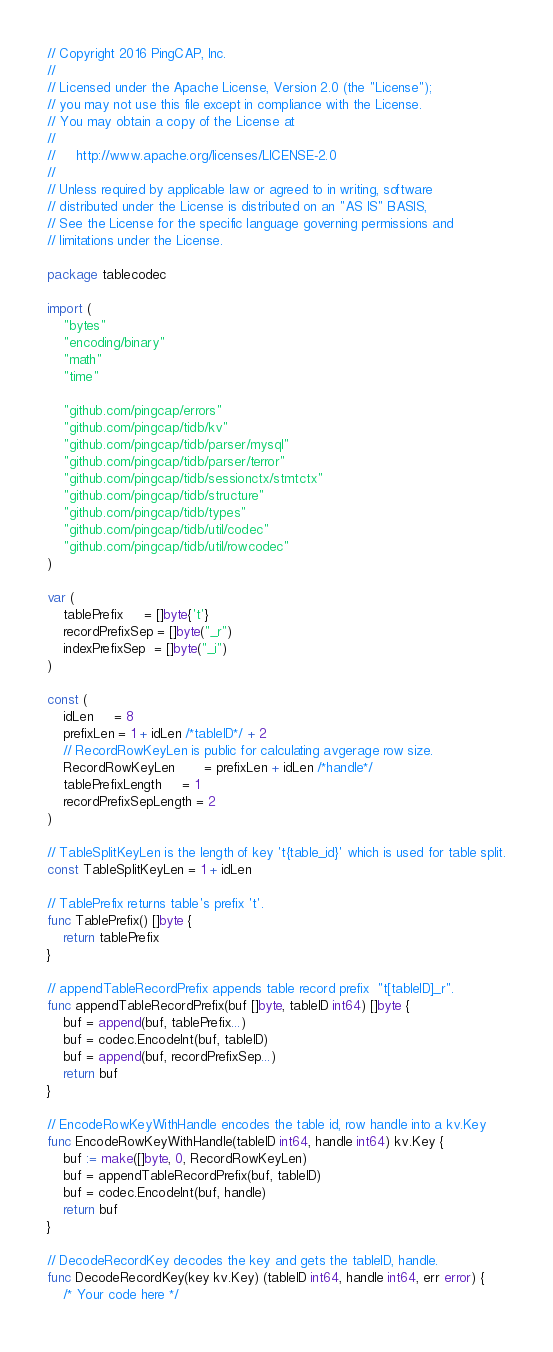Convert code to text. <code><loc_0><loc_0><loc_500><loc_500><_Go_>// Copyright 2016 PingCAP, Inc.
//
// Licensed under the Apache License, Version 2.0 (the "License");
// you may not use this file except in compliance with the License.
// You may obtain a copy of the License at
//
//     http://www.apache.org/licenses/LICENSE-2.0
//
// Unless required by applicable law or agreed to in writing, software
// distributed under the License is distributed on an "AS IS" BASIS,
// See the License for the specific language governing permissions and
// limitations under the License.

package tablecodec

import (
	"bytes"
	"encoding/binary"
	"math"
	"time"

	"github.com/pingcap/errors"
	"github.com/pingcap/tidb/kv"
	"github.com/pingcap/tidb/parser/mysql"
	"github.com/pingcap/tidb/parser/terror"
	"github.com/pingcap/tidb/sessionctx/stmtctx"
	"github.com/pingcap/tidb/structure"
	"github.com/pingcap/tidb/types"
	"github.com/pingcap/tidb/util/codec"
	"github.com/pingcap/tidb/util/rowcodec"
)

var (
	tablePrefix     = []byte{'t'}
	recordPrefixSep = []byte("_r")
	indexPrefixSep  = []byte("_i")
)

const (
	idLen     = 8
	prefixLen = 1 + idLen /*tableID*/ + 2
	// RecordRowKeyLen is public for calculating avgerage row size.
	RecordRowKeyLen       = prefixLen + idLen /*handle*/
	tablePrefixLength     = 1
	recordPrefixSepLength = 2
)

// TableSplitKeyLen is the length of key 't{table_id}' which is used for table split.
const TableSplitKeyLen = 1 + idLen

// TablePrefix returns table's prefix 't'.
func TablePrefix() []byte {
	return tablePrefix
}

// appendTableRecordPrefix appends table record prefix  "t[tableID]_r".
func appendTableRecordPrefix(buf []byte, tableID int64) []byte {
	buf = append(buf, tablePrefix...)
	buf = codec.EncodeInt(buf, tableID)
	buf = append(buf, recordPrefixSep...)
	return buf
}

// EncodeRowKeyWithHandle encodes the table id, row handle into a kv.Key
func EncodeRowKeyWithHandle(tableID int64, handle int64) kv.Key {
	buf := make([]byte, 0, RecordRowKeyLen)
	buf = appendTableRecordPrefix(buf, tableID)
	buf = codec.EncodeInt(buf, handle)
	return buf
}

// DecodeRecordKey decodes the key and gets the tableID, handle.
func DecodeRecordKey(key kv.Key) (tableID int64, handle int64, err error) {
	/* Your code here */</code> 